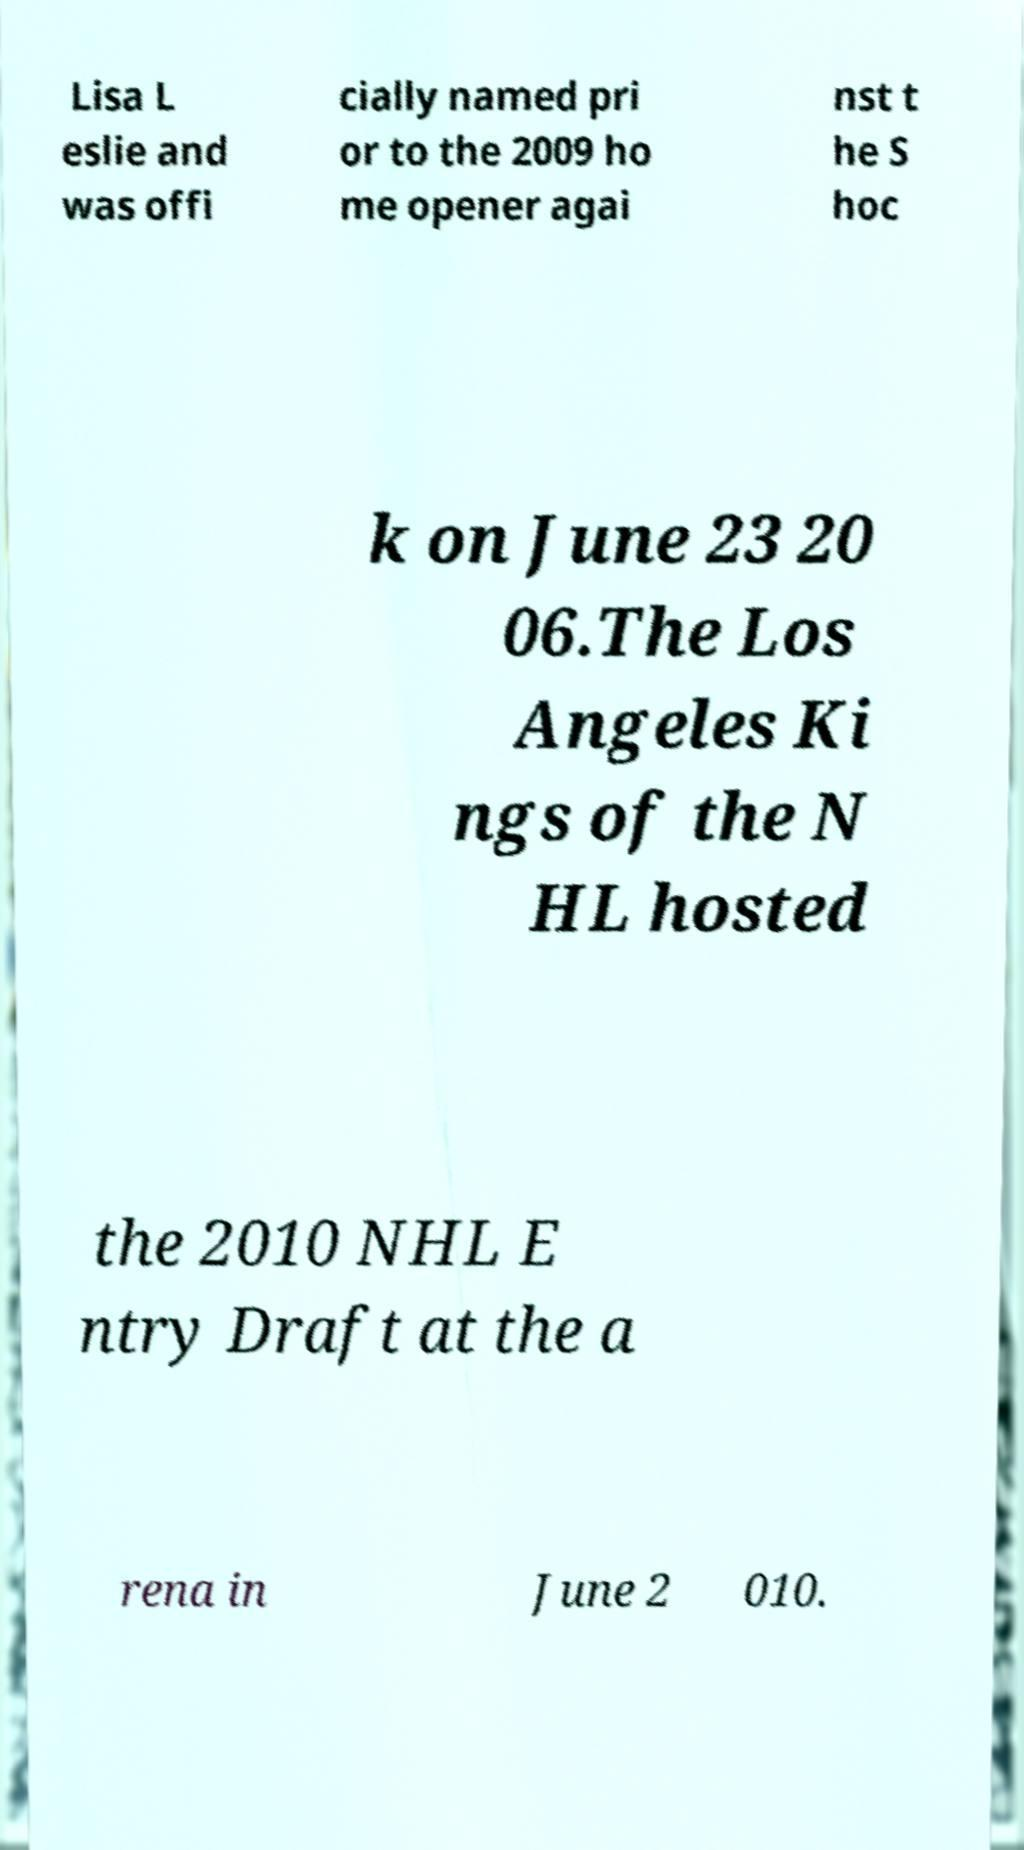Could you extract and type out the text from this image? Lisa L eslie and was offi cially named pri or to the 2009 ho me opener agai nst t he S hoc k on June 23 20 06.The Los Angeles Ki ngs of the N HL hosted the 2010 NHL E ntry Draft at the a rena in June 2 010. 